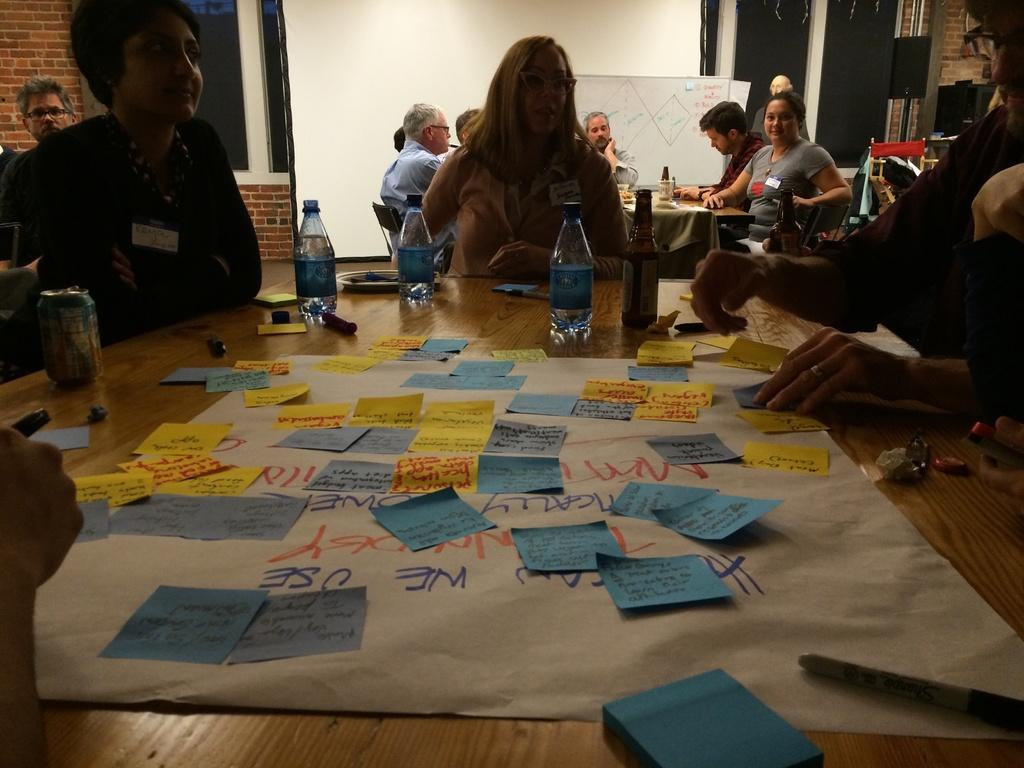How many people are in the image? There is a group of people in the image. What are the people doing in the image? The people are sitting on a chair. Where is the chair located in relation to the table? The chair is in front of a table. What can be seen on the table besides the people? There are water bottles and other objects on the table. What type of badge is the person wearing in the image? There is no person wearing a badge in the image. What place is depicted in the image? The image does not depict a specific place; it only shows a group of people sitting on a chair in front of a table. 